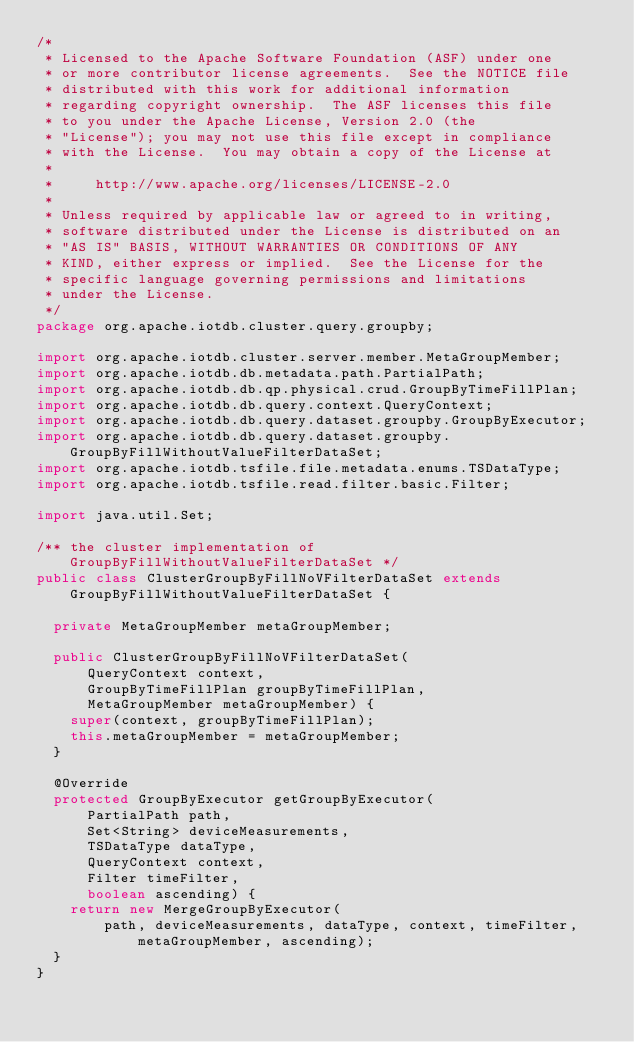<code> <loc_0><loc_0><loc_500><loc_500><_Java_>/*
 * Licensed to the Apache Software Foundation (ASF) under one
 * or more contributor license agreements.  See the NOTICE file
 * distributed with this work for additional information
 * regarding copyright ownership.  The ASF licenses this file
 * to you under the Apache License, Version 2.0 (the
 * "License"); you may not use this file except in compliance
 * with the License.  You may obtain a copy of the License at
 *
 *     http://www.apache.org/licenses/LICENSE-2.0
 *
 * Unless required by applicable law or agreed to in writing,
 * software distributed under the License is distributed on an
 * "AS IS" BASIS, WITHOUT WARRANTIES OR CONDITIONS OF ANY
 * KIND, either express or implied.  See the License for the
 * specific language governing permissions and limitations
 * under the License.
 */
package org.apache.iotdb.cluster.query.groupby;

import org.apache.iotdb.cluster.server.member.MetaGroupMember;
import org.apache.iotdb.db.metadata.path.PartialPath;
import org.apache.iotdb.db.qp.physical.crud.GroupByTimeFillPlan;
import org.apache.iotdb.db.query.context.QueryContext;
import org.apache.iotdb.db.query.dataset.groupby.GroupByExecutor;
import org.apache.iotdb.db.query.dataset.groupby.GroupByFillWithoutValueFilterDataSet;
import org.apache.iotdb.tsfile.file.metadata.enums.TSDataType;
import org.apache.iotdb.tsfile.read.filter.basic.Filter;

import java.util.Set;

/** the cluster implementation of GroupByFillWithoutValueFilterDataSet */
public class ClusterGroupByFillNoVFilterDataSet extends GroupByFillWithoutValueFilterDataSet {

  private MetaGroupMember metaGroupMember;

  public ClusterGroupByFillNoVFilterDataSet(
      QueryContext context,
      GroupByTimeFillPlan groupByTimeFillPlan,
      MetaGroupMember metaGroupMember) {
    super(context, groupByTimeFillPlan);
    this.metaGroupMember = metaGroupMember;
  }

  @Override
  protected GroupByExecutor getGroupByExecutor(
      PartialPath path,
      Set<String> deviceMeasurements,
      TSDataType dataType,
      QueryContext context,
      Filter timeFilter,
      boolean ascending) {
    return new MergeGroupByExecutor(
        path, deviceMeasurements, dataType, context, timeFilter, metaGroupMember, ascending);
  }
}
</code> 